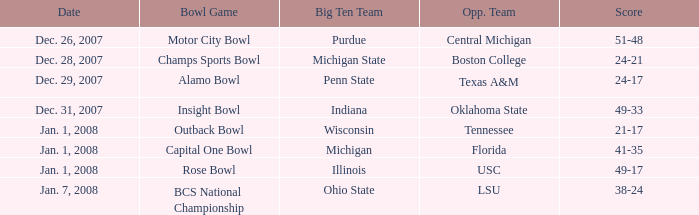Can you give me this table as a dict? {'header': ['Date', 'Bowl Game', 'Big Ten Team', 'Opp. Team', 'Score'], 'rows': [['Dec. 26, 2007', 'Motor City Bowl', 'Purdue', 'Central Michigan', '51-48'], ['Dec. 28, 2007', 'Champs Sports Bowl', 'Michigan State', 'Boston College', '24-21'], ['Dec. 29, 2007', 'Alamo Bowl', 'Penn State', 'Texas A&M', '24-17'], ['Dec. 31, 2007', 'Insight Bowl', 'Indiana', 'Oklahoma State', '49-33'], ['Jan. 1, 2008', 'Outback Bowl', 'Wisconsin', 'Tennessee', '21-17'], ['Jan. 1, 2008', 'Capital One Bowl', 'Michigan', 'Florida', '41-35'], ['Jan. 1, 2008', 'Rose Bowl', 'Illinois', 'USC', '49-17'], ['Jan. 7, 2008', 'BCS National Championship', 'Ohio State', 'LSU', '38-24']]} What was the outcome of the bcs national championship game? 38-24. 